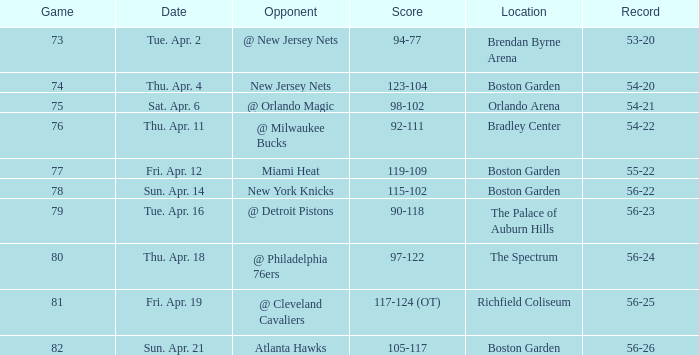When was the score 56-26? Sun. Apr. 21. 